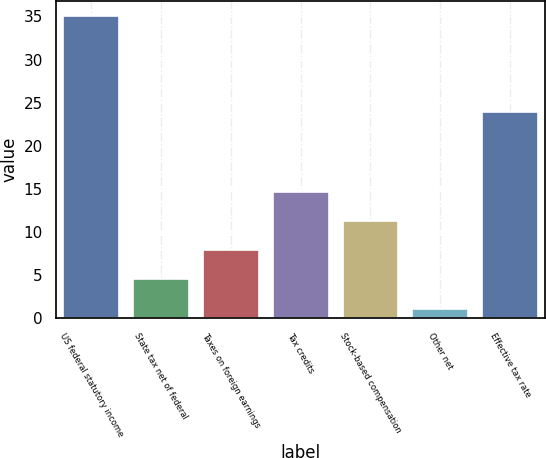Convert chart. <chart><loc_0><loc_0><loc_500><loc_500><bar_chart><fcel>US federal statutory income<fcel>State tax net of federal<fcel>Taxes on foreign earnings<fcel>Tax credits<fcel>Stock-based compensation<fcel>Other net<fcel>Effective tax rate<nl><fcel>35<fcel>4.5<fcel>7.89<fcel>14.67<fcel>11.28<fcel>1.11<fcel>23.96<nl></chart> 